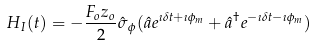<formula> <loc_0><loc_0><loc_500><loc_500>H _ { I } ( t ) = - \frac { F _ { o } z _ { o } } { 2 } \hat { \sigma } _ { \, \phi } ( \hat { a } e ^ { \imath \delta t + \imath \phi _ { m } } + \hat { a } ^ { \dag } e ^ { - \imath \delta t - \imath \phi _ { m } } )</formula> 